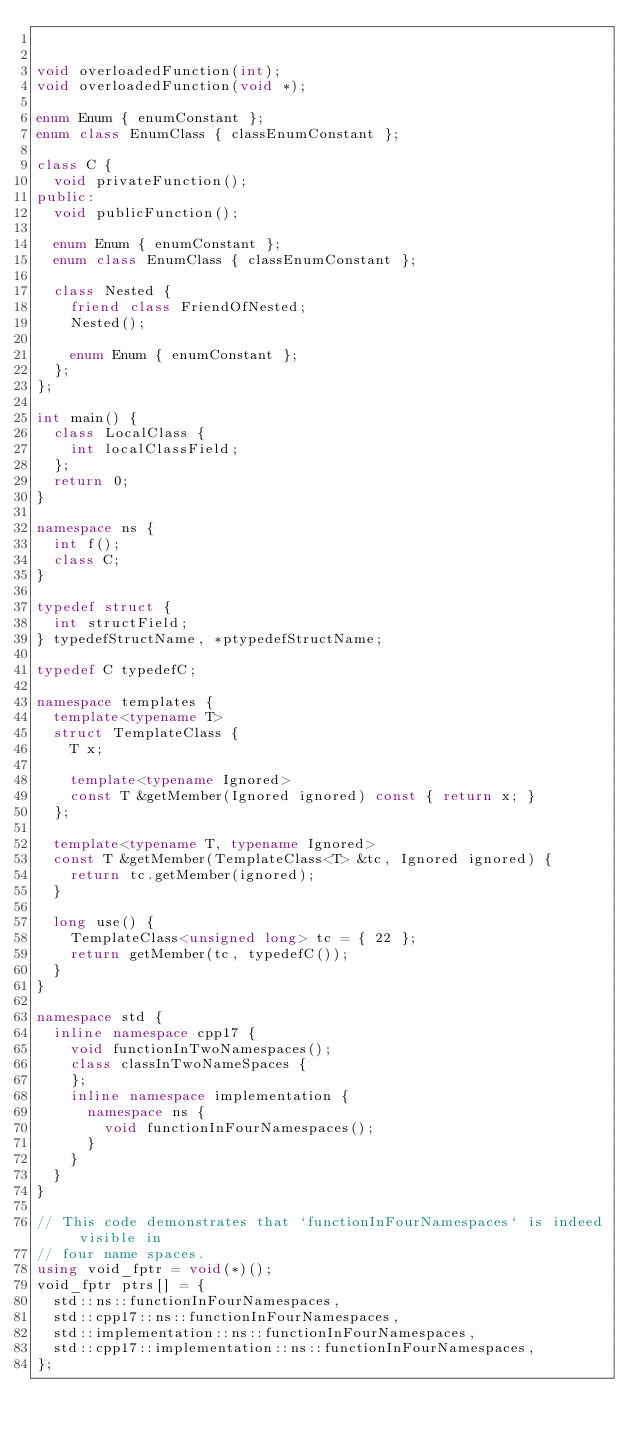Convert code to text. <code><loc_0><loc_0><loc_500><loc_500><_C++_>

void overloadedFunction(int);
void overloadedFunction(void *);

enum Enum { enumConstant };
enum class EnumClass { classEnumConstant };

class C {
  void privateFunction();
public:
  void publicFunction();

  enum Enum { enumConstant };
  enum class EnumClass { classEnumConstant };

  class Nested {
    friend class FriendOfNested;
    Nested();

    enum Enum { enumConstant };
  };
};

int main() {
  class LocalClass {
    int localClassField;
  };
  return 0;
}

namespace ns {
  int f();
  class C;
}

typedef struct {
  int structField;
} typedefStructName, *ptypedefStructName;

typedef C typedefC;

namespace templates {
  template<typename T>
  struct TemplateClass {
    T x;

    template<typename Ignored>
    const T &getMember(Ignored ignored) const { return x; }
  };

  template<typename T, typename Ignored>
  const T &getMember(TemplateClass<T> &tc, Ignored ignored) {
    return tc.getMember(ignored);
  }

  long use() {
    TemplateClass<unsigned long> tc = { 22 };
    return getMember(tc, typedefC());
  }
}

namespace std {
  inline namespace cpp17 {
    void functionInTwoNamespaces();
    class classInTwoNameSpaces {
    };
    inline namespace implementation {
      namespace ns {
        void functionInFourNamespaces();
      }
    }
  }
}

// This code demonstrates that `functionInFourNamespaces` is indeed visible in
// four name spaces.
using void_fptr = void(*)();
void_fptr ptrs[] = {
  std::ns::functionInFourNamespaces,
  std::cpp17::ns::functionInFourNamespaces,
  std::implementation::ns::functionInFourNamespaces,
  std::cpp17::implementation::ns::functionInFourNamespaces,
};
</code> 